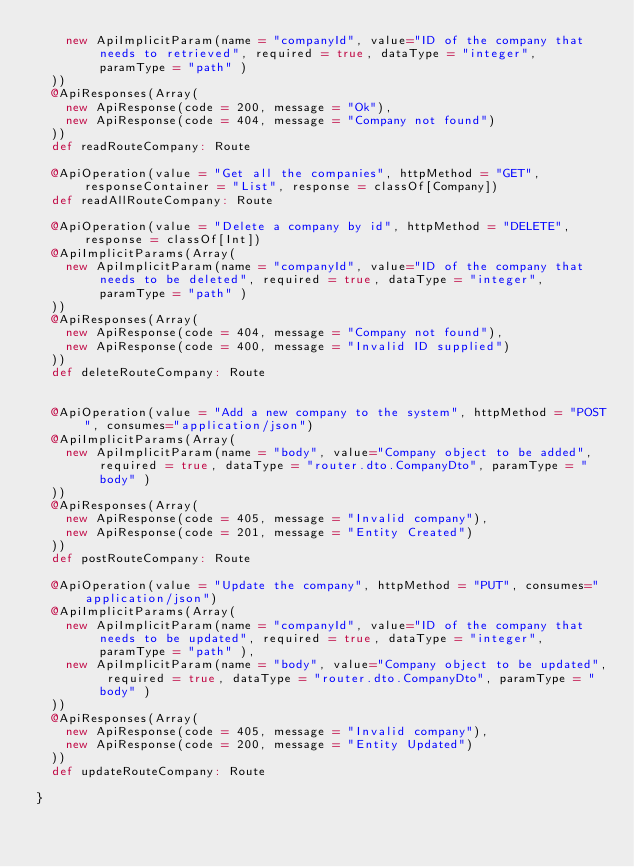<code> <loc_0><loc_0><loc_500><loc_500><_Scala_>    new ApiImplicitParam(name = "companyId", value="ID of the company that needs to retrieved", required = true, dataType = "integer", paramType = "path" )
  ))
  @ApiResponses(Array(
    new ApiResponse(code = 200, message = "Ok"),
    new ApiResponse(code = 404, message = "Company not found")
  ))
  def readRouteCompany: Route

  @ApiOperation(value = "Get all the companies", httpMethod = "GET", responseContainer = "List", response = classOf[Company])
  def readAllRouteCompany: Route

  @ApiOperation(value = "Delete a company by id", httpMethod = "DELETE", response = classOf[Int])
  @ApiImplicitParams(Array(
    new ApiImplicitParam(name = "companyId", value="ID of the company that needs to be deleted", required = true, dataType = "integer", paramType = "path" )
  ))
  @ApiResponses(Array(
    new ApiResponse(code = 404, message = "Company not found"),
    new ApiResponse(code = 400, message = "Invalid ID supplied")
  ))
  def deleteRouteCompany: Route


  @ApiOperation(value = "Add a new company to the system", httpMethod = "POST", consumes="application/json")
  @ApiImplicitParams(Array(
    new ApiImplicitParam(name = "body", value="Company object to be added", required = true, dataType = "router.dto.CompanyDto", paramType = "body" )
  ))
  @ApiResponses(Array(
    new ApiResponse(code = 405, message = "Invalid company"),
    new ApiResponse(code = 201, message = "Entity Created")
  ))
  def postRouteCompany: Route

  @ApiOperation(value = "Update the company", httpMethod = "PUT", consumes="application/json")
  @ApiImplicitParams(Array(
    new ApiImplicitParam(name = "companyId", value="ID of the company that needs to be updated", required = true, dataType = "integer", paramType = "path" ),
    new ApiImplicitParam(name = "body", value="Company object to be updated", required = true, dataType = "router.dto.CompanyDto", paramType = "body" )
  ))
  @ApiResponses(Array(
    new ApiResponse(code = 405, message = "Invalid company"),
    new ApiResponse(code = 200, message = "Entity Updated")
  ))
  def updateRouteCompany: Route

}
</code> 